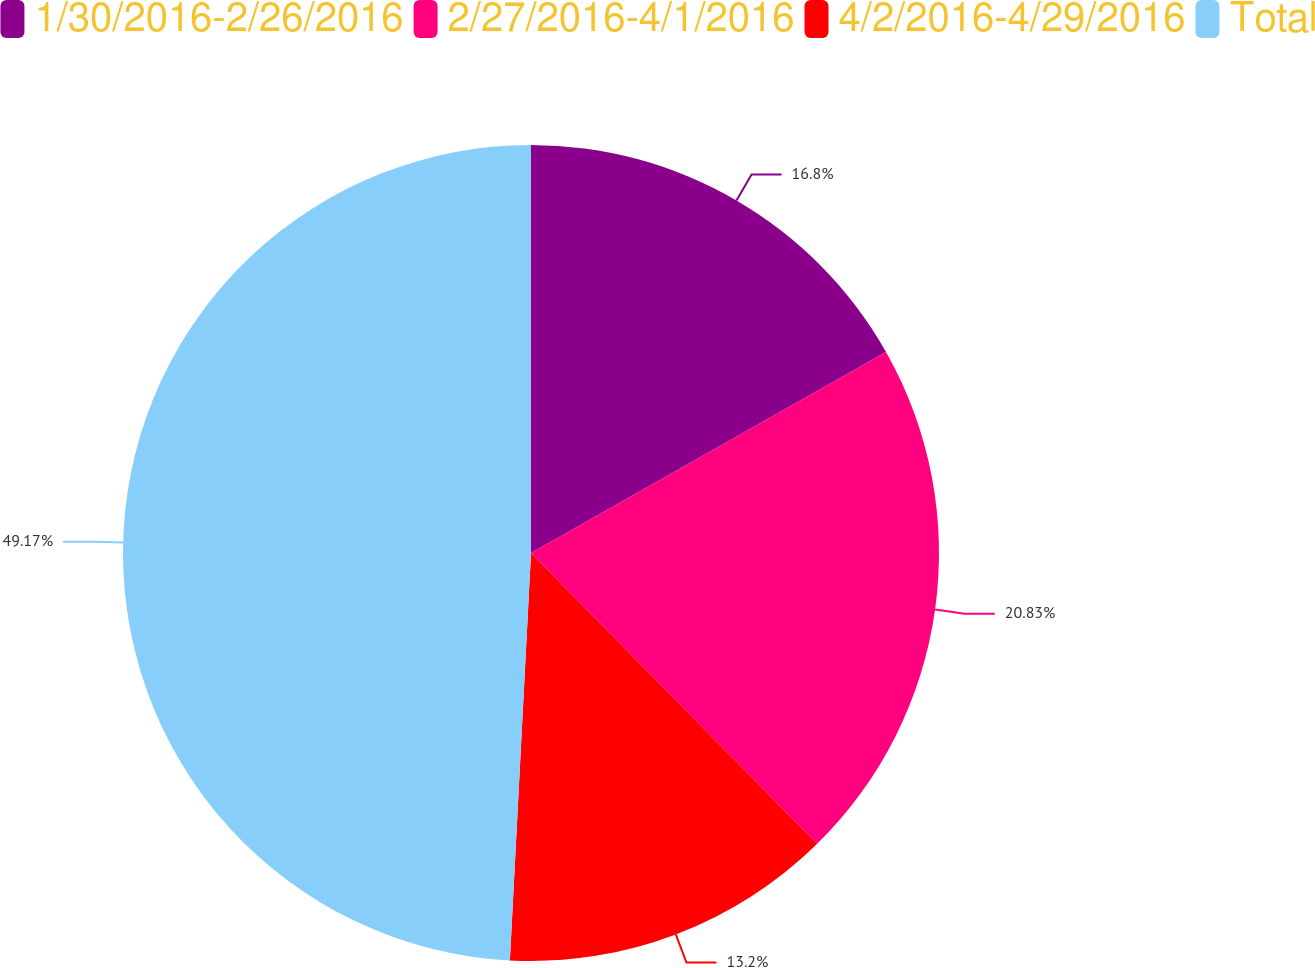<chart> <loc_0><loc_0><loc_500><loc_500><pie_chart><fcel>1/30/2016-2/26/2016<fcel>2/27/2016-4/1/2016<fcel>4/2/2016-4/29/2016<fcel>Total<nl><fcel>16.8%<fcel>20.83%<fcel>13.2%<fcel>49.18%<nl></chart> 